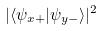<formula> <loc_0><loc_0><loc_500><loc_500>| \langle \psi _ { x + } | \psi _ { y - } \rangle | ^ { 2 }</formula> 